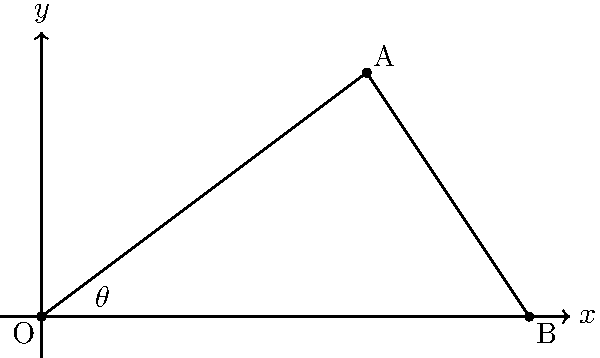In your fantasy world, a dragon takes flight from point O (0,0) and soars to point A (8,6). A knight observes this from point B (12,0). Calculate the angle $\theta$ of the dragon's flight path relative to the horizontal, rounded to the nearest degree. To find the angle $\theta$ of the dragon's flight path, we'll use the slope of the line OA and the arctangent function. Here's how:

1) First, calculate the slope of line OA:
   $m = \frac{y_2 - y_1}{x_2 - x_1} = \frac{6 - 0}{8 - 0} = \frac{6}{8} = 0.75$

2) The slope represents the tangent of the angle $\theta$:
   $\tan(\theta) = 0.75$

3) To find $\theta$, we use the arctangent (inverse tangent) function:
   $\theta = \arctan(0.75)$

4) Using a calculator or computer:
   $\theta \approx 0.6435$ radians

5) Convert to degrees:
   $\theta \approx 0.6435 \times \frac{180}{\pi} \approx 36.87°$

6) Rounding to the nearest degree:
   $\theta \approx 37°$

This angle represents the dragon's flight path relative to the horizontal, as observed from the origin.
Answer: $37°$ 